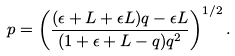<formula> <loc_0><loc_0><loc_500><loc_500>p = \left ( \frac { ( \epsilon + L + \epsilon L ) q - \epsilon L } { ( 1 + \epsilon + L - q ) q ^ { 2 } } \right ) ^ { 1 / 2 } .</formula> 